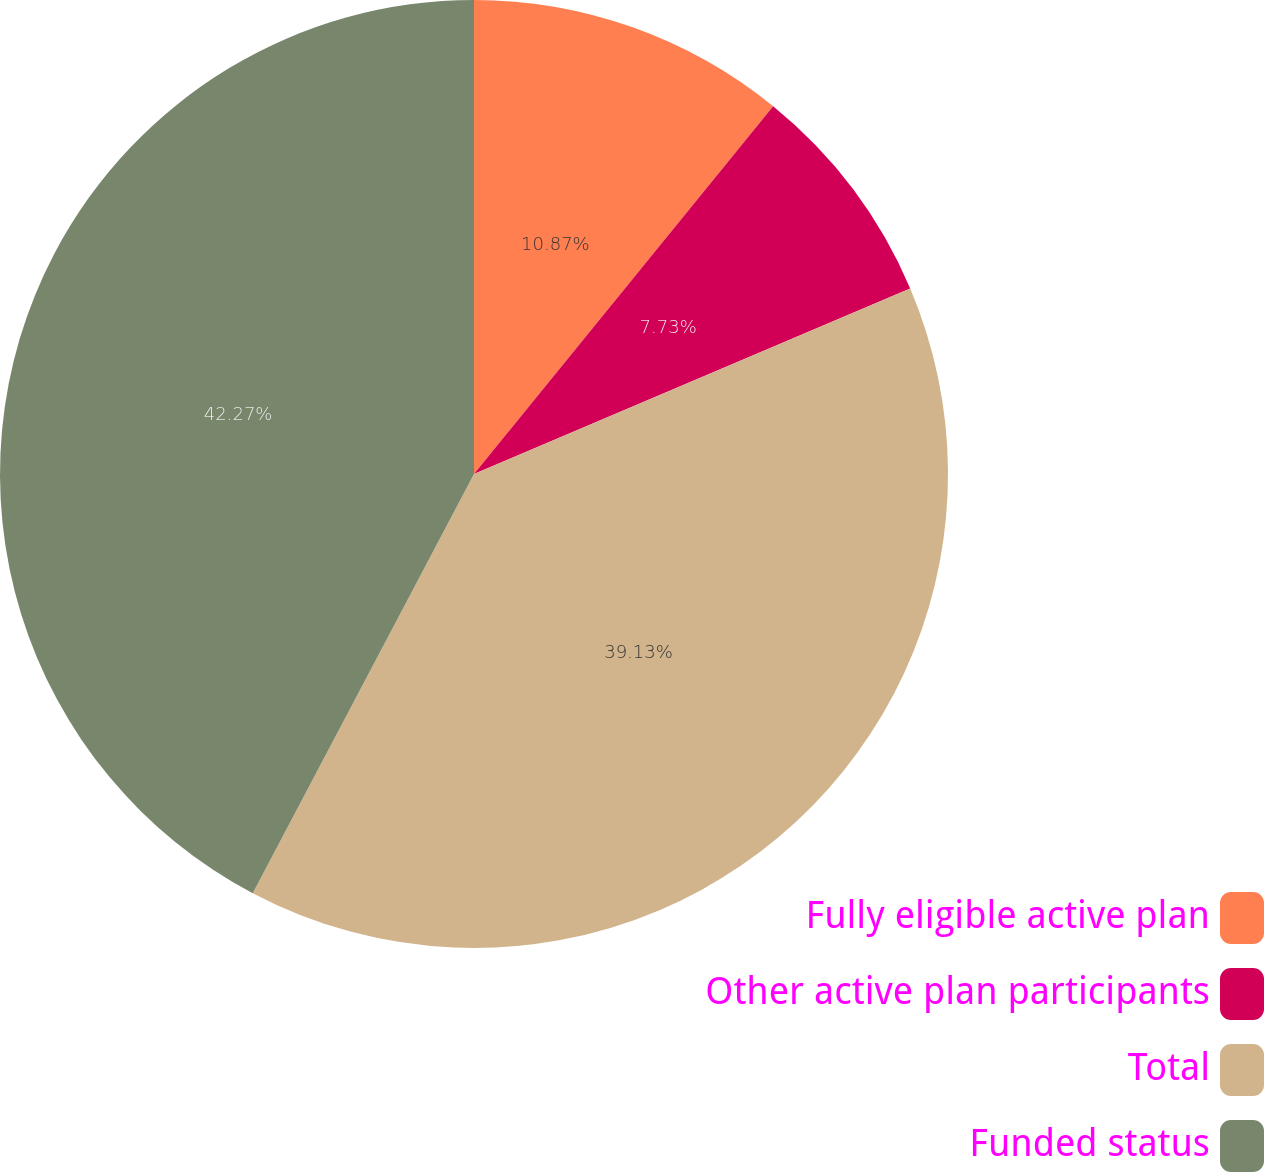<chart> <loc_0><loc_0><loc_500><loc_500><pie_chart><fcel>Fully eligible active plan<fcel>Other active plan participants<fcel>Total<fcel>Funded status<nl><fcel>10.87%<fcel>7.73%<fcel>39.13%<fcel>42.27%<nl></chart> 